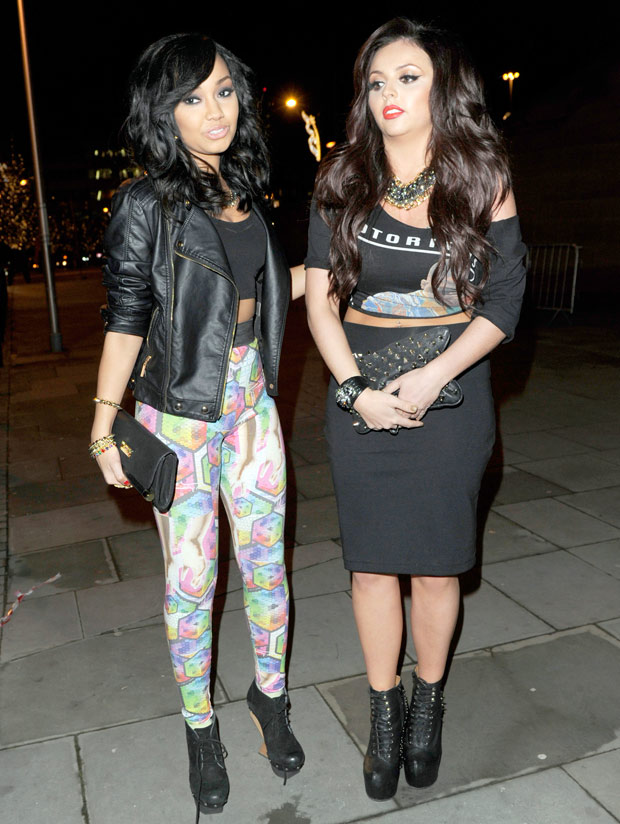Imagine a creative story based on this photo. Once upon a time, in a city where nightfall awakened a hidden world of magic, two friends embarked on an extraordinary adventure. Underneath the soft glow of enchanted streetlights, their outfits changed hues with the rhythm of their heartbeats, blending them seamlessly into the ever-shifting mosaic of the urban landscape. They were not just attending a typical event; they were the city's chosen guardians for the night. Carrying enchanted artifacts concealed within their stylish clutches, they moved gracefully towards the midnight portal—a secret entrance hidden in plain sight, embedded in the very pathways they walked. Their mission: to restore balance by retrieving lost fragments of the city's soul, stolen by shadowy entities that lurked in the twilight. Their journey took them through mystical parks where trees whispered ancient secrets, to rooftops where the stars themselves seemed to guide their path. By dawn, they would have danced through dimensions, leaving the world of common nightclubs and parties far behind, returning only when the first light of morning promised a new day. Expand on how their magical outfits help them on the mission. Their outfits were more than just fashionable statements; they were meticulously crafted by elder artisans of the hidden world to serve unique purposes. The leather jacket worn by one friend contained hidden pockets that could store elements of light and shadow, allowing her to navigate through the darkest alleys or become invisible when needed. Her colorful leggings, enchanted with runes of speed, enabled her to move swiftly, outpacing any pursuers. The elegant dress of the other shimmered under the moonlight, capable of reflecting spells cast upon them, turning attacks into a dazzling display of harmless sparks. Her jewelry wasn't mere ornamentation; the necklace allowed her to communicate with the spirits of the city, gathering vital information and guidance. The bracelets amplified her physical strength, making her an unstoppable force against any obstacles. Together, their outfits not only protected them but also enabled them to interact with the city's magical elements, from summoning helpful beings made of light to gaining access to mystic hidden pathways. These garments were their armor and their key to restoring the balance of the night. 